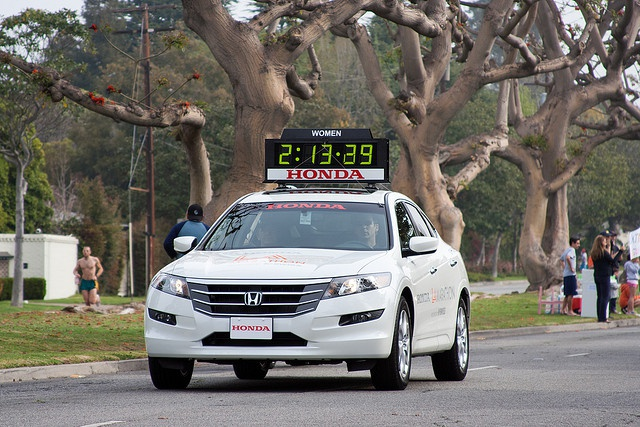Describe the objects in this image and their specific colors. I can see car in lightgray, black, darkgray, and gray tones, clock in lavender, black, lightgray, maroon, and lime tones, people in lavender, black, gray, and lightgray tones, people in lavender, black, maroon, navy, and gray tones, and people in lavender, gray, brown, tan, and black tones in this image. 